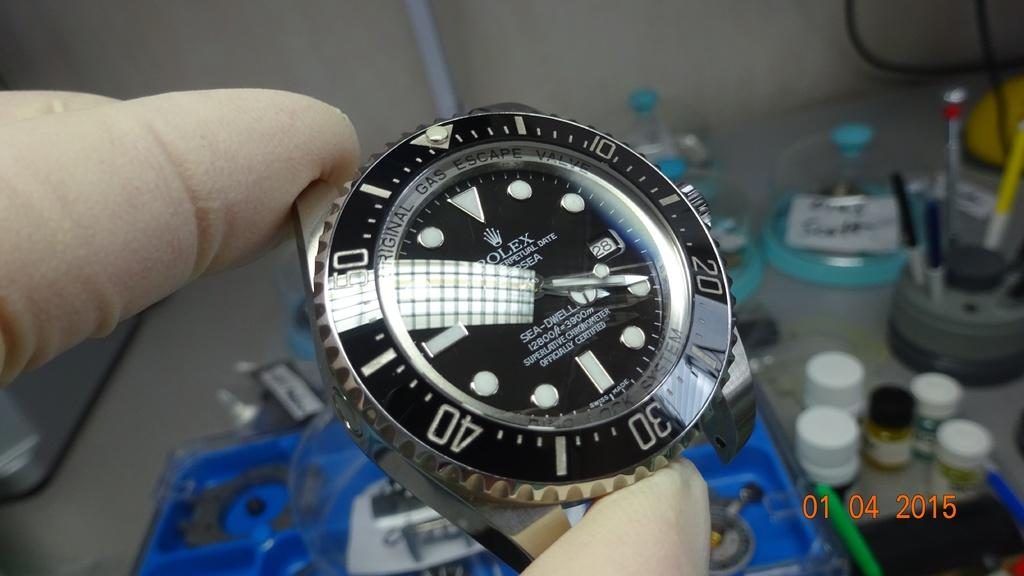<image>
Offer a succinct explanation of the picture presented. Person holding a black and silver watch that says ROLEX on the face. 